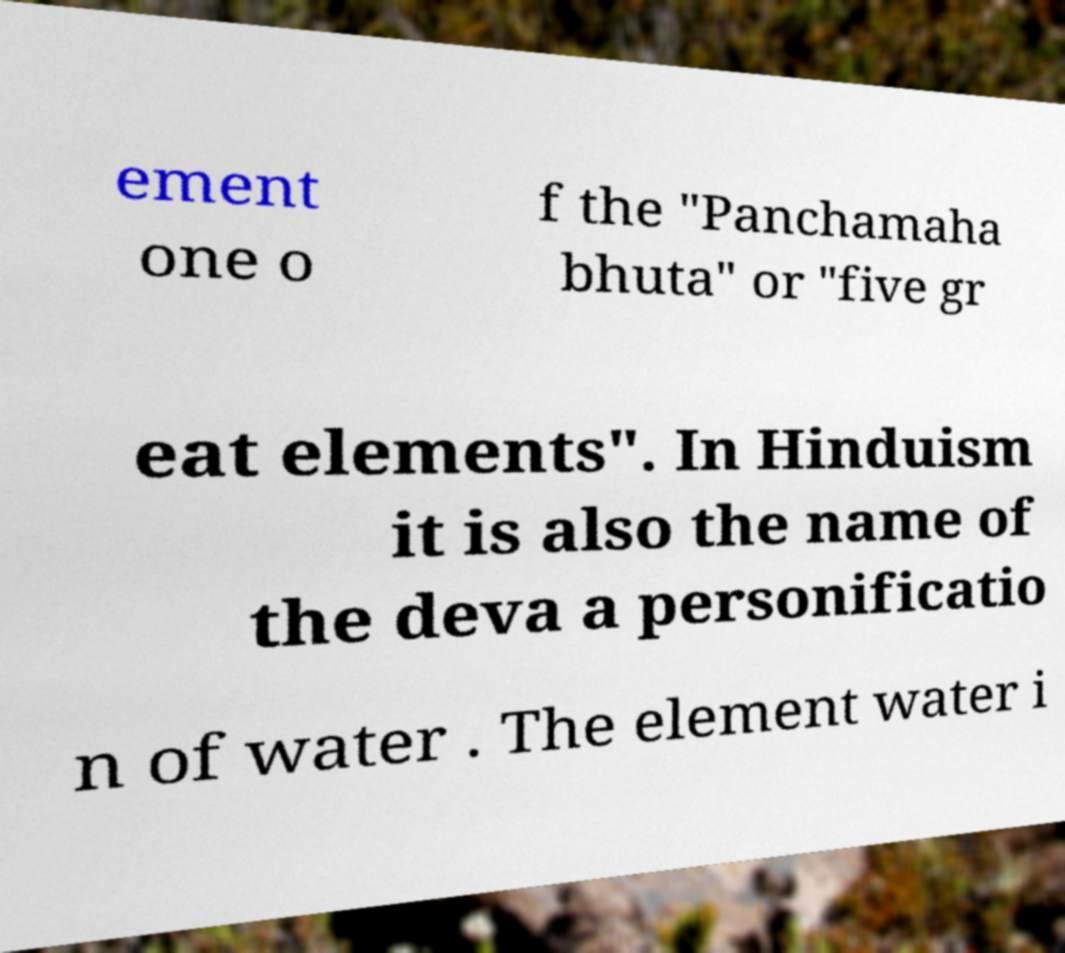For documentation purposes, I need the text within this image transcribed. Could you provide that? ement one o f the "Panchamaha bhuta" or "five gr eat elements". In Hinduism it is also the name of the deva a personificatio n of water . The element water i 